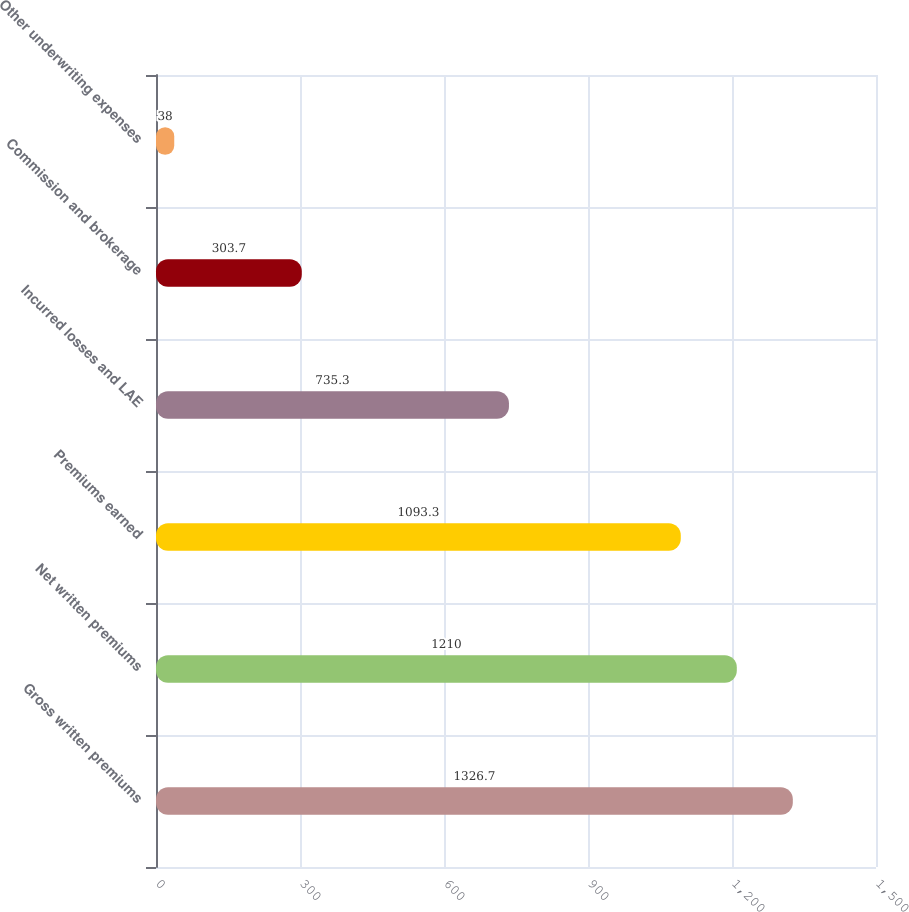Convert chart. <chart><loc_0><loc_0><loc_500><loc_500><bar_chart><fcel>Gross written premiums<fcel>Net written premiums<fcel>Premiums earned<fcel>Incurred losses and LAE<fcel>Commission and brokerage<fcel>Other underwriting expenses<nl><fcel>1326.7<fcel>1210<fcel>1093.3<fcel>735.3<fcel>303.7<fcel>38<nl></chart> 